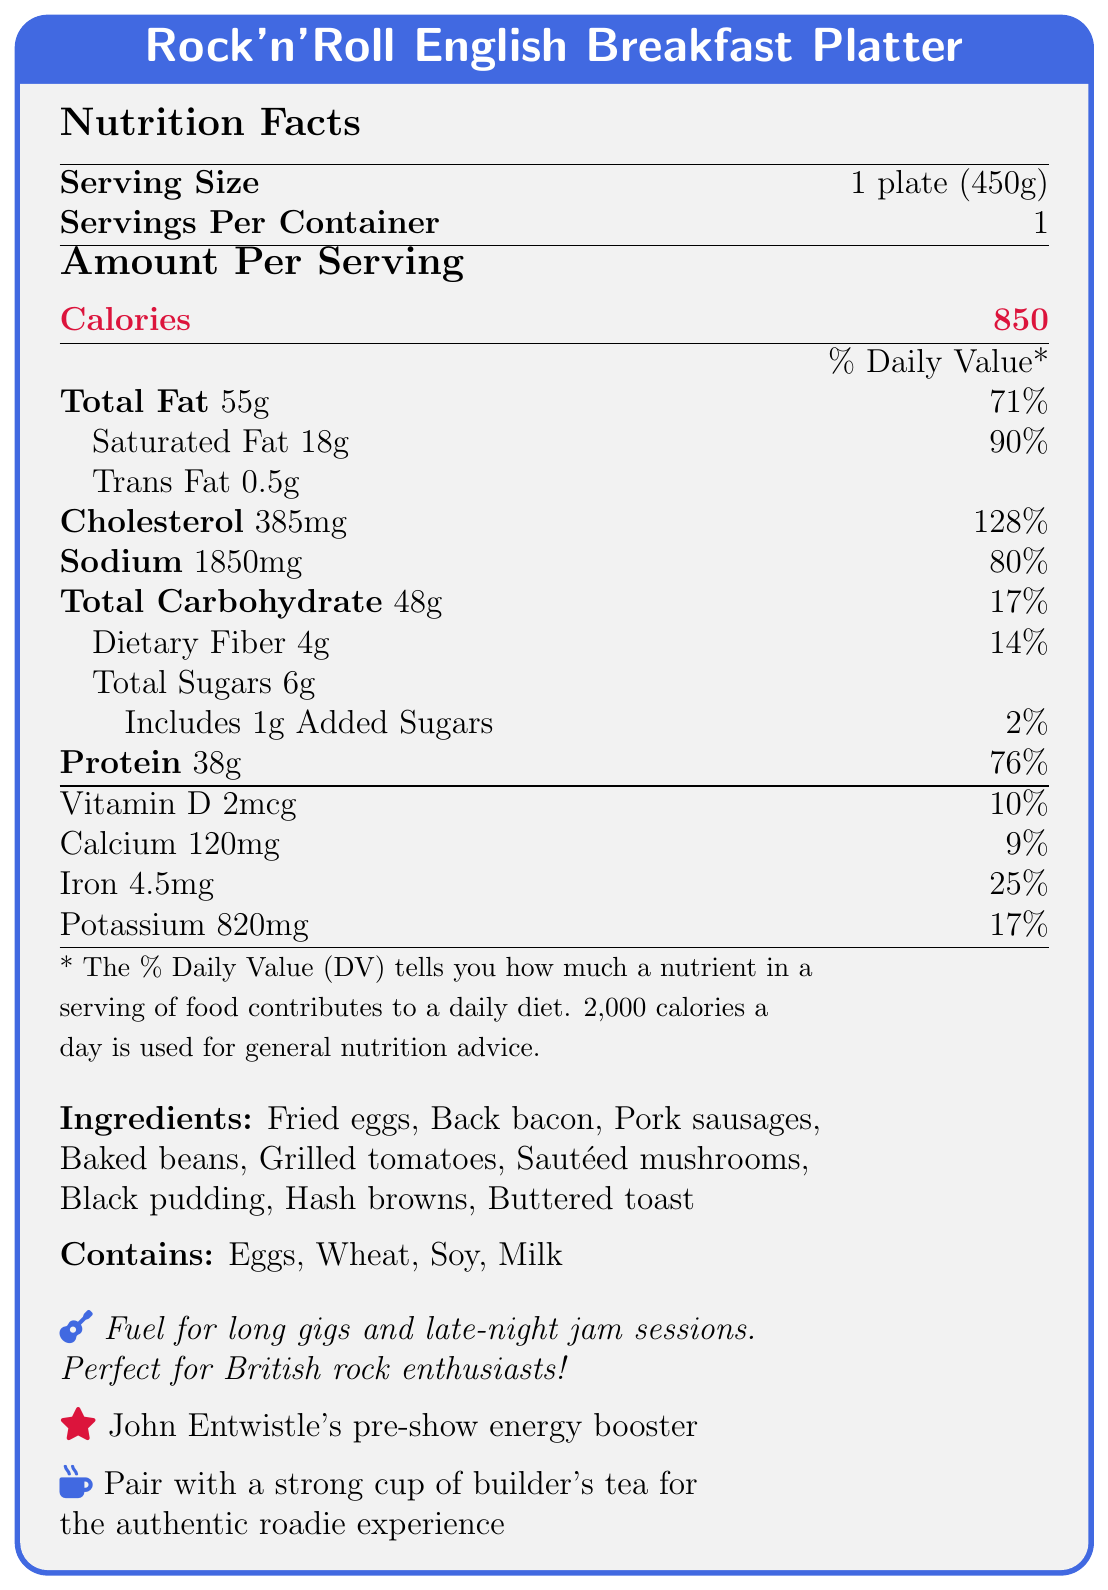What is the calorie content per serving? The document specifies that each serving of the English Breakfast Platter contains 850 calories.
Answer: 850 calories What is the total fat content per serving, and what percentage of the daily value does it represent? The document states that the total fat content per serving is 55g, which represents 71% of the daily value.
Answer: 55g, 71% How much protein does the Rock'n'Roll English Breakfast Platter contain? According to the document, the Rock'n'Roll English Breakfast Platter contains 38g of protein.
Answer: 38g Which nutrient has the highest percentage of the daily value in the breakfast platter? The document shows that cholesterol's daily value is 128%, which is the highest among the listed nutrients.
Answer: Cholesterol What are the allergens listed in the document? The document mentions that the allergens present are Eggs, Wheat, Soy, and Milk.
Answer: Eggs, Wheat, Soy, Milk How much sodium does one serving of the Rock'n'Roll English Breakfast Platter contain? The document indicates that one serving contains 1850mg of sodium.
Answer: 1850mg What is the serving size of the Rock'n'Roll English Breakfast Platter? The document specifies that the serving size is 1 plate (450g).
Answer: 1 plate (450g) How many grams of dietary fiber are in this breakfast? The document states that the breakfast contains 4g of dietary fiber.
Answer: 4g How much saturated fat does the breakfast platter contain and what percentage of the daily value does it cover? The document indicates the saturated fat content is 18g, covering 90% of the daily value.
Answer: 18g, 90% What is the recommended beverage to pair with the breakfast platter? The document suggests pairing the breakfast platter with a strong cup of builder's tea.
Answer: Builder's tea Which bandmate is mentioned as recommending the Rock'n'Roll English Breakfast Platter? The document mentions that John Entwistle recommends it as a pre-show energy booster.
Answer: John Entwistle What is the special note about the breakfast platter? The document includes a special note stating that the platter is fuel for long gigs and late-night jam sessions, perfect for British rock enthusiasts.
Answer: Fuel for long gigs and late-night jam sessions. Perfect for British rock enthusiasts! How much cholesterol is in a serving of the breakfast platter? The document indicates that a serving contains 385mg of cholesterol.
Answer: 385mg What is the main carbohydrate component in the breakfast platter? While the document lists multiple ingredients, baked beans are a primary carbohydrate-rich component.
Answer: Baked beans Which of the following is NOT listed as an ingredient in the breakfast platter? A. Fried eggs B. Pancakes C. Pork sausages D. Grilled tomatoes The document does not list pancakes as an ingredient.
Answer: B. Pancakes Which vitamin contributes 10% of its daily value per serving of the breakfast platter? According to the document, Vitamin D contributes 10% of its daily value per serving.
Answer: Vitamin D Is trans fat content listed in the nutrition facts? The document lists the trans fat content as 0.5g.
Answer: Yes What is the total carbohydrate content in the breakfast platter and its daily value percentage? The document states that the total carbohydrate content is 48g, which is 17% of the daily value.
Answer: 48g, 17% Can you determine the specific calories contribution from fat in the breakfast platter from the document? The document provides total fat grams but not the specific calories attributed to fat.
Answer: Not enough information Summarize the nutritional profile of the Rock'n'Roll English Breakfast Platter. The explanation summarizes the key nutritional elements, ingredients, and allergens, providing an overview of the platter's health profile.
Answer: The Rock'n'Roll English Breakfast Platter contains 850 calories per serving (450g), with 55g of total fat (71% daily value), 18g of saturated fat (90% DV), 0.5g of trans fat, and 385mg of cholesterol (128% DV). It includes 1850mg of sodium (80% DV), 48g of total carbohydrates (17% DV), 4g of dietary fiber (14% DV), 6g of total sugars (including 1g of added sugars at 2% DV), and 38g of protein (76% DV). It also provides 2mcg of Vitamin D (10% DV), 120mg of calcium (9% DV), 4.5mg of iron (25% DV), and 820mg of potassium (17% DV). Ingredients include fried eggs, back bacon, pork sausages, baked beans, grilled tomatoes, sautéed mushrooms, black pudding, hash browns, and buttered toast. Allergens: eggs, wheat, soy, milk. 